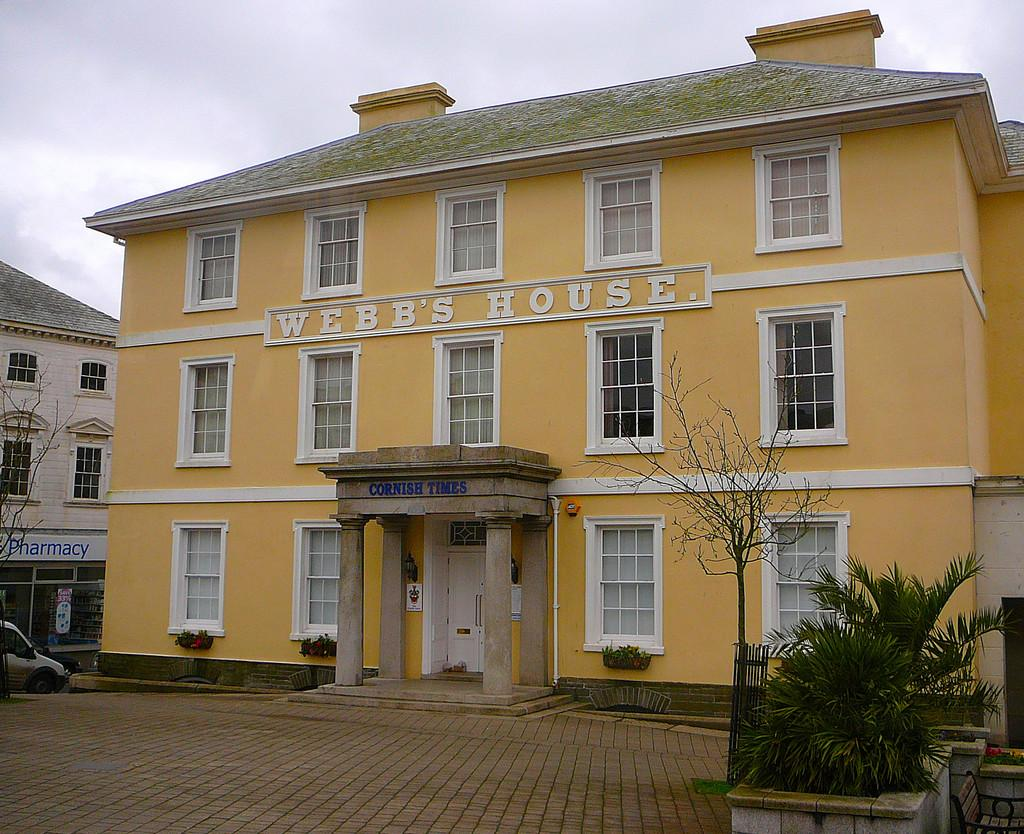What type of structures are present in the image? There are buildings in the image. What can be seen on the right side of the image? There are plants and a tree on the right side of the image. What is located on the left side of the image? There is a car on the left side of the image. What is visible in the background of the image? The sky is visible in the background of the image. How much jam is being sold by the tree in the image? There is no jam or indication of a sale in the image; it features a tree and plants on the right side. Can you tell me how much money the snake is carrying in the image? There is no snake present in the image; it features buildings, plants, a tree, a car, and the sky. 